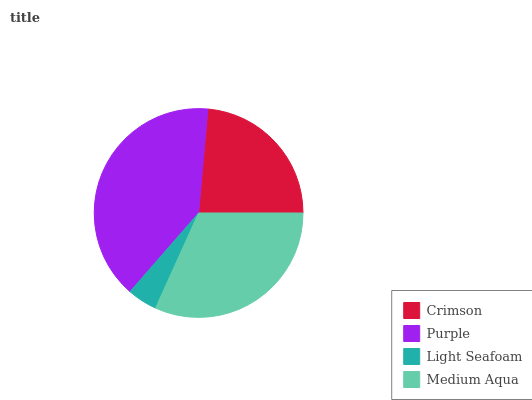Is Light Seafoam the minimum?
Answer yes or no. Yes. Is Purple the maximum?
Answer yes or no. Yes. Is Purple the minimum?
Answer yes or no. No. Is Light Seafoam the maximum?
Answer yes or no. No. Is Purple greater than Light Seafoam?
Answer yes or no. Yes. Is Light Seafoam less than Purple?
Answer yes or no. Yes. Is Light Seafoam greater than Purple?
Answer yes or no. No. Is Purple less than Light Seafoam?
Answer yes or no. No. Is Medium Aqua the high median?
Answer yes or no. Yes. Is Crimson the low median?
Answer yes or no. Yes. Is Light Seafoam the high median?
Answer yes or no. No. Is Light Seafoam the low median?
Answer yes or no. No. 